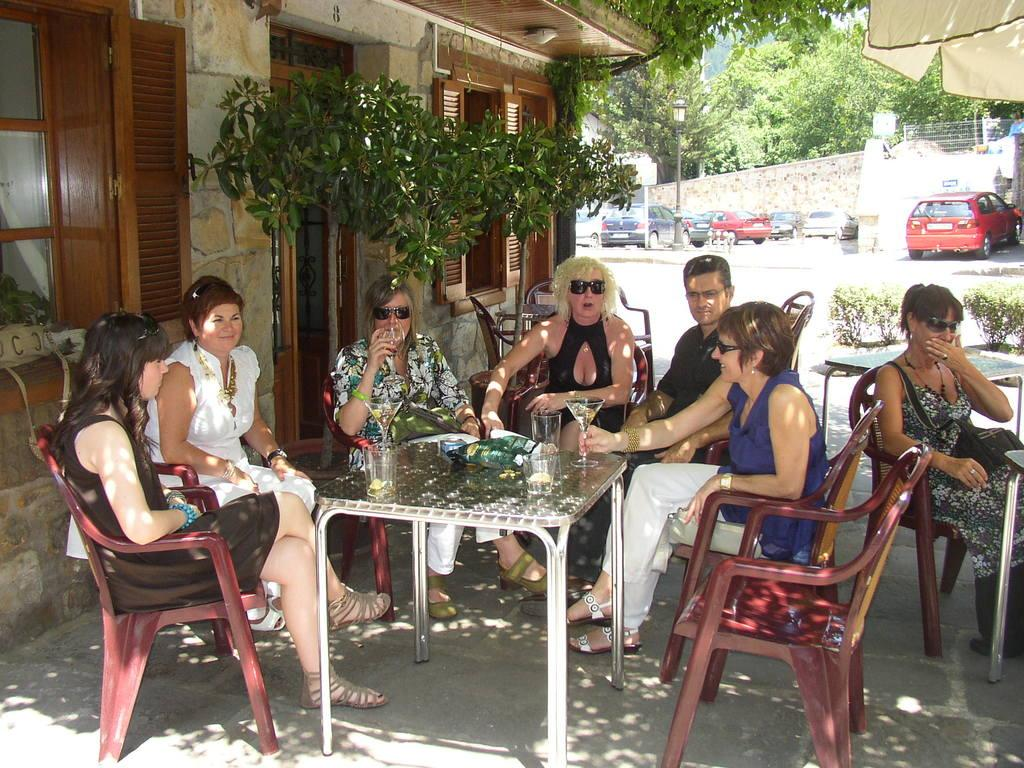What are the people in the image doing? People are sitting on chairs near a table in the image. What can be found on the table? There is a glass on the table. What can be seen in the distance behind the people? Vehicles, a tree, and a house are visible in the background. Where is the boy playing volleyball in the image? There is no boy playing volleyball in the image. What type of quartz can be seen on the table in the image? There is no quartz present on the table in the image. 